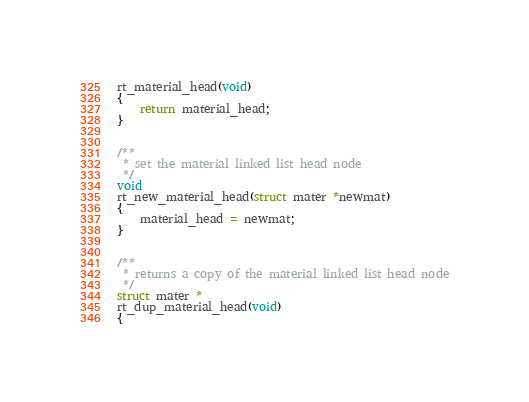<code> <loc_0><loc_0><loc_500><loc_500><_C_>rt_material_head(void)
{
    return material_head;
}


/**
 * set the material linked list head node
 */
void
rt_new_material_head(struct mater *newmat)
{
    material_head = newmat;
}


/**
 * returns a copy of the material linked list head node
 */
struct mater *
rt_dup_material_head(void)
{</code> 